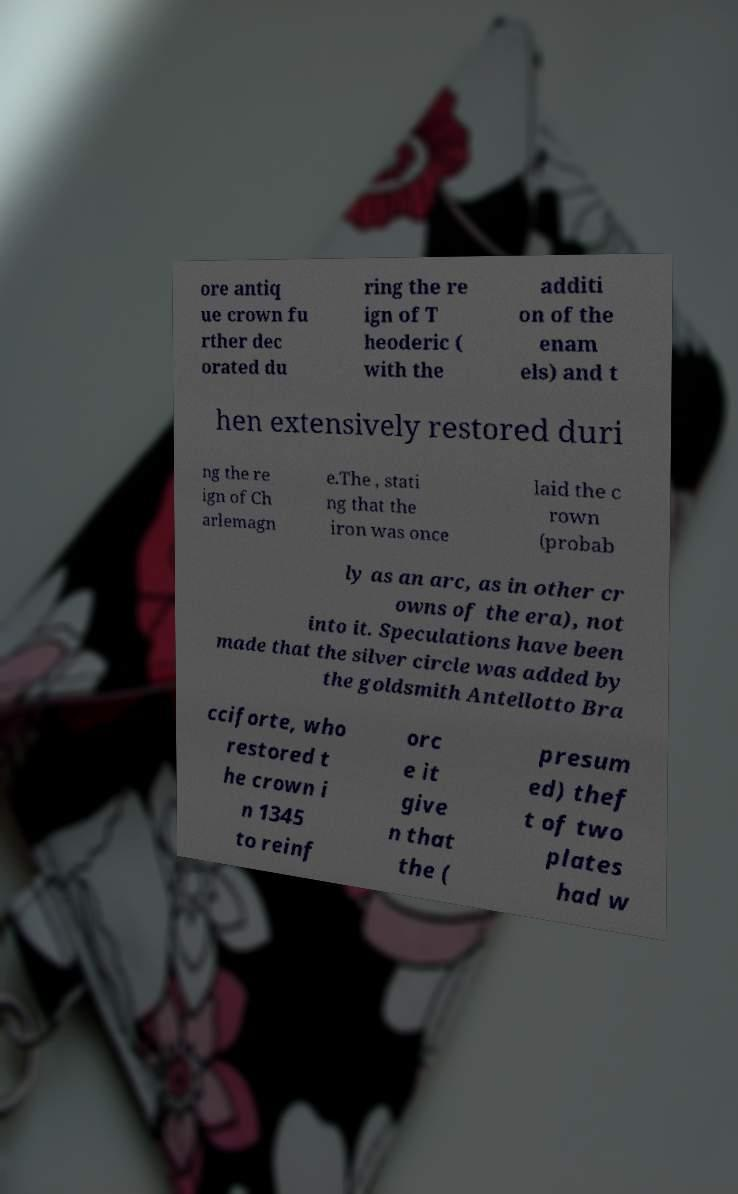There's text embedded in this image that I need extracted. Can you transcribe it verbatim? ore antiq ue crown fu rther dec orated du ring the re ign of T heoderic ( with the additi on of the enam els) and t hen extensively restored duri ng the re ign of Ch arlemagn e.The , stati ng that the iron was once laid the c rown (probab ly as an arc, as in other cr owns of the era), not into it. Speculations have been made that the silver circle was added by the goldsmith Antellotto Bra cciforte, who restored t he crown i n 1345 to reinf orc e it give n that the ( presum ed) thef t of two plates had w 